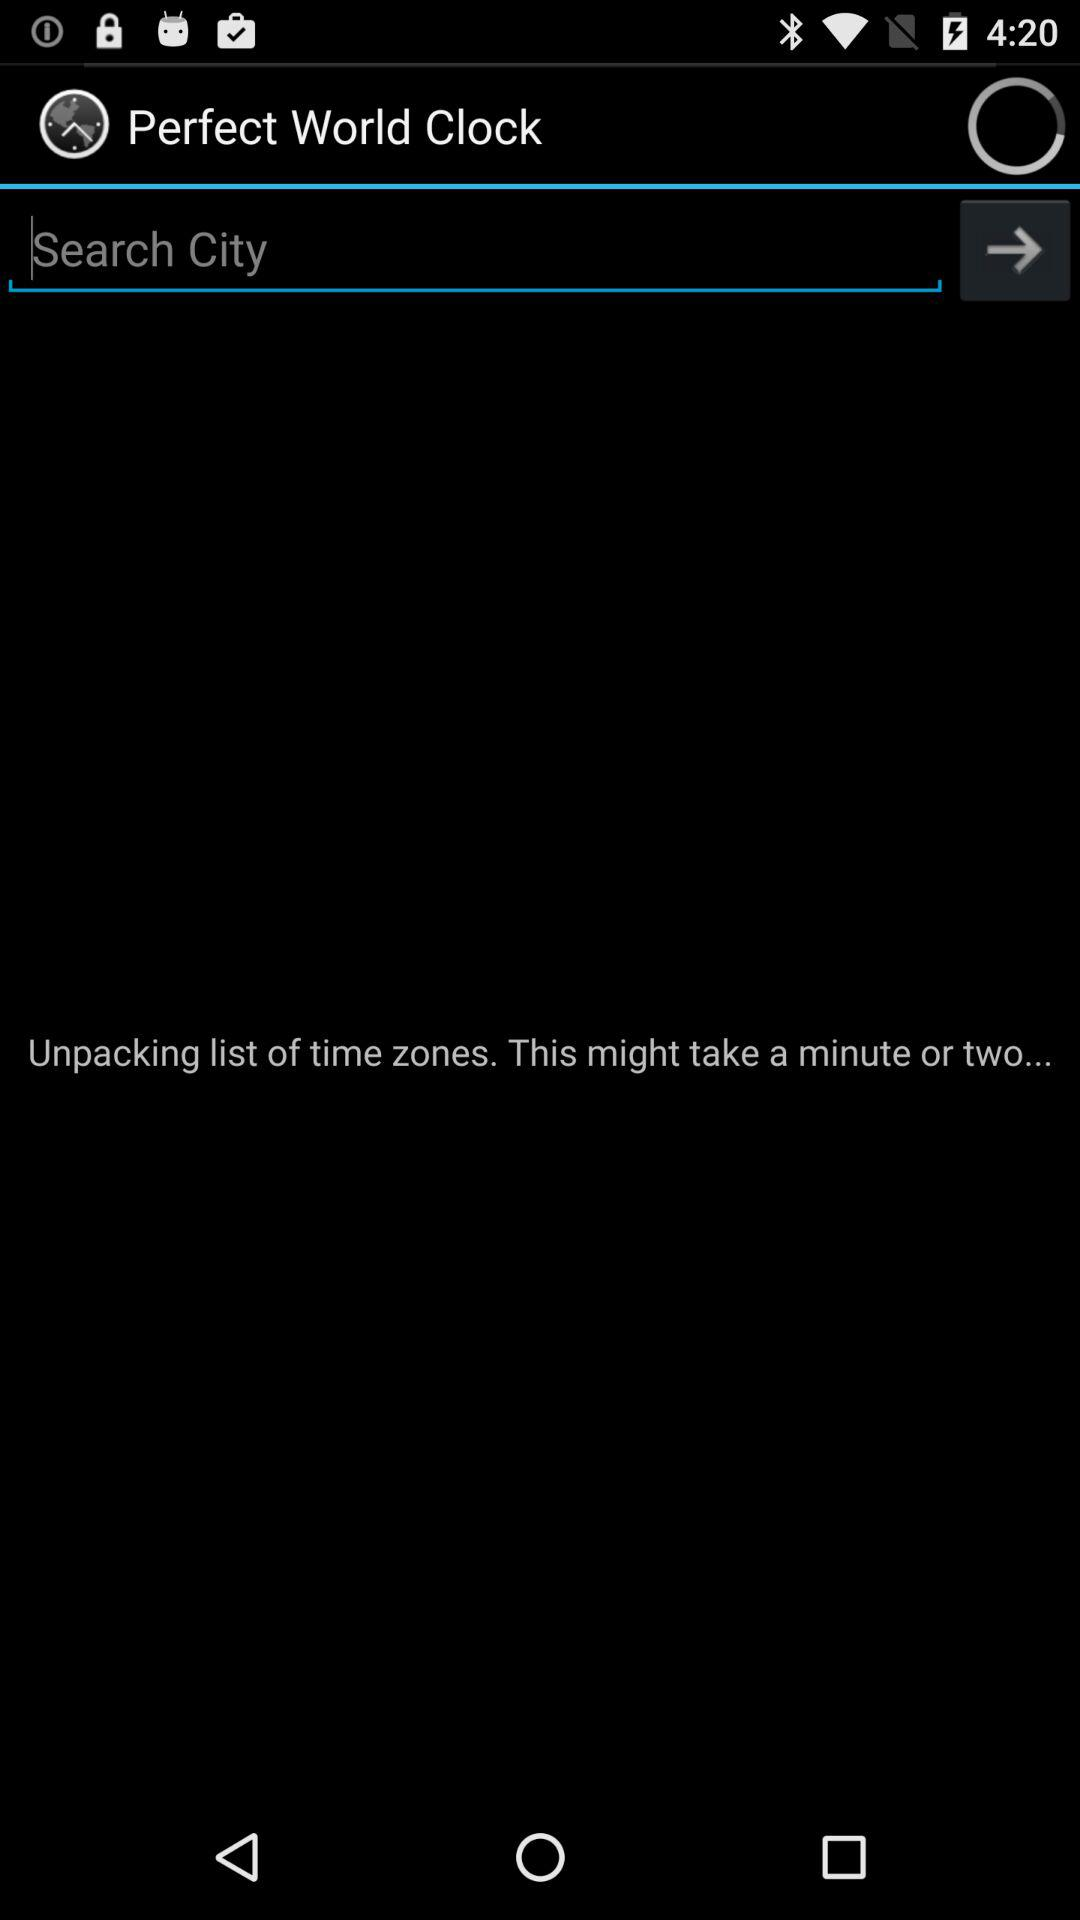What is the application name? The application name is "Perfect World Clock". 